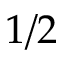Convert formula to latex. <formula><loc_0><loc_0><loc_500><loc_500>1 / 2</formula> 